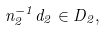Convert formula to latex. <formula><loc_0><loc_0><loc_500><loc_500>n _ { 2 } ^ { - 1 } d _ { 2 } \in D _ { 2 } ,</formula> 